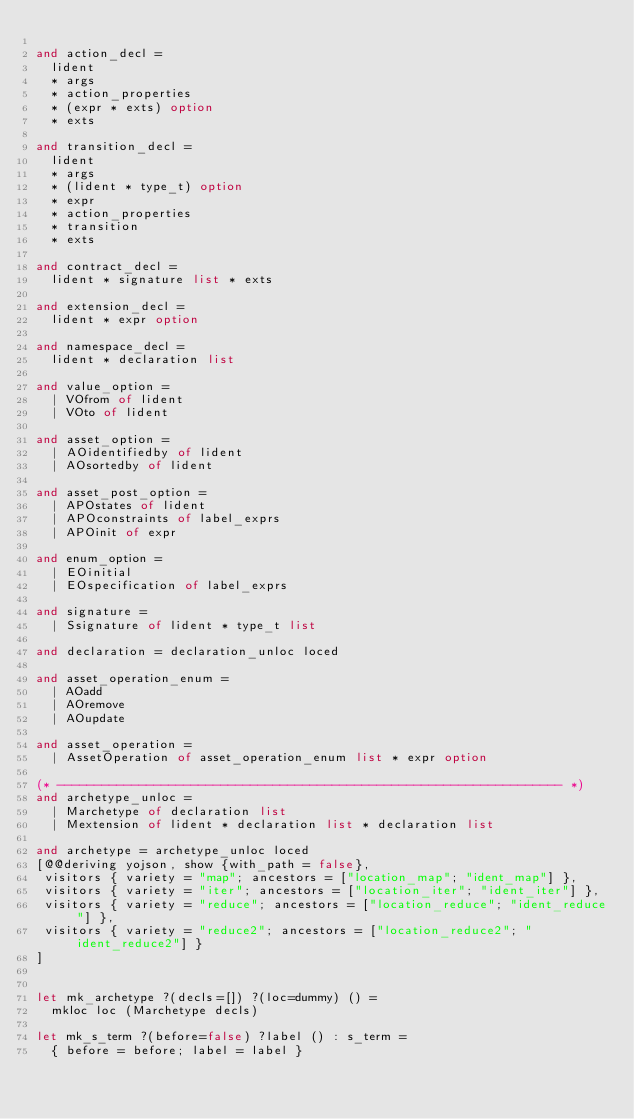<code> <loc_0><loc_0><loc_500><loc_500><_OCaml_>
and action_decl =
  lident
  * args
  * action_properties
  * (expr * exts) option
  * exts

and transition_decl =
  lident
  * args
  * (lident * type_t) option
  * expr
  * action_properties
  * transition
  * exts

and contract_decl =
  lident * signature list * exts

and extension_decl =
  lident * expr option

and namespace_decl =
  lident * declaration list

and value_option =
  | VOfrom of lident
  | VOto of lident

and asset_option =
  | AOidentifiedby of lident
  | AOsortedby of lident

and asset_post_option =
  | APOstates of lident
  | APOconstraints of label_exprs
  | APOinit of expr

and enum_option =
  | EOinitial
  | EOspecification of label_exprs

and signature =
  | Ssignature of lident * type_t list

and declaration = declaration_unloc loced

and asset_operation_enum =
  | AOadd
  | AOremove
  | AOupdate

and asset_operation =
  | AssetOperation of asset_operation_enum list * expr option

(* -------------------------------------------------------------------- *)
and archetype_unloc =
  | Marchetype of declaration list
  | Mextension of lident * declaration list * declaration list

and archetype = archetype_unloc loced
[@@deriving yojson, show {with_path = false},
 visitors { variety = "map"; ancestors = ["location_map"; "ident_map"] },
 visitors { variety = "iter"; ancestors = ["location_iter"; "ident_iter"] },
 visitors { variety = "reduce"; ancestors = ["location_reduce"; "ident_reduce"] },
 visitors { variety = "reduce2"; ancestors = ["location_reduce2"; "ident_reduce2"] }
]


let mk_archetype ?(decls=[]) ?(loc=dummy) () =
  mkloc loc (Marchetype decls)

let mk_s_term ?(before=false) ?label () : s_term =
  { before = before; label = label }
</code> 